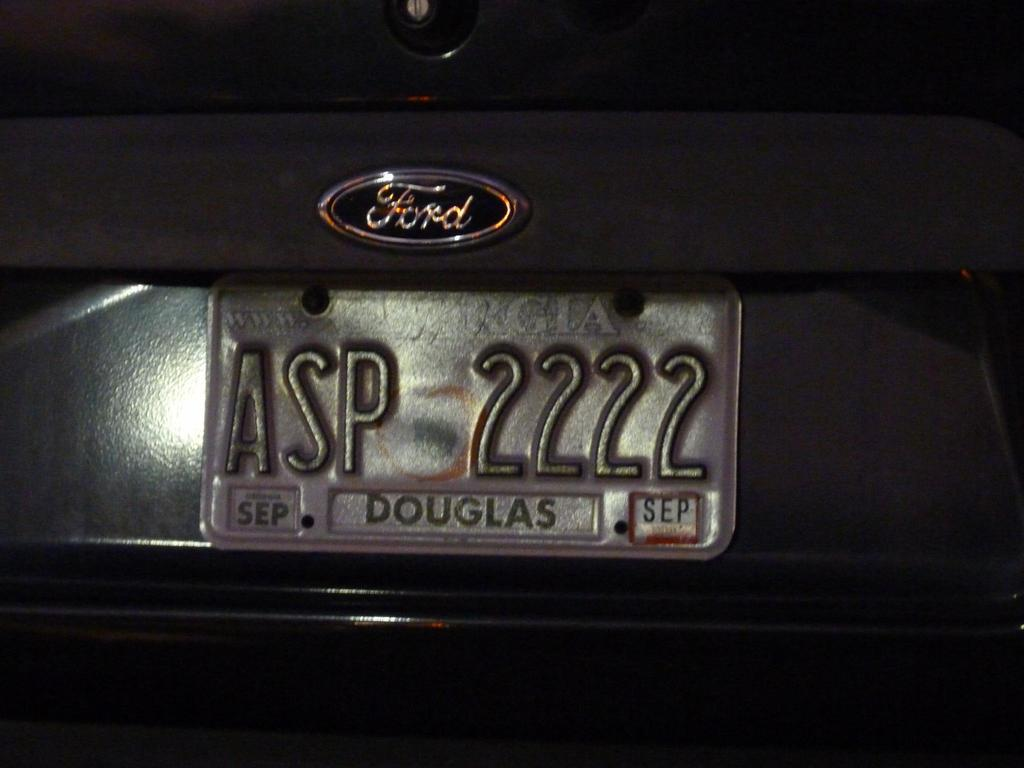What can be seen in the image related to a vehicle? There is a number plate of a vehicle in the image. Can you describe the number plate in the image? The number plate is a rectangular metal or plastic plate with numbers and letters on it, typically attached to the front and rear of a vehicle. What time is displayed on the clock in the image? There is no clock present in the image; it only features a number plate of a vehicle. 